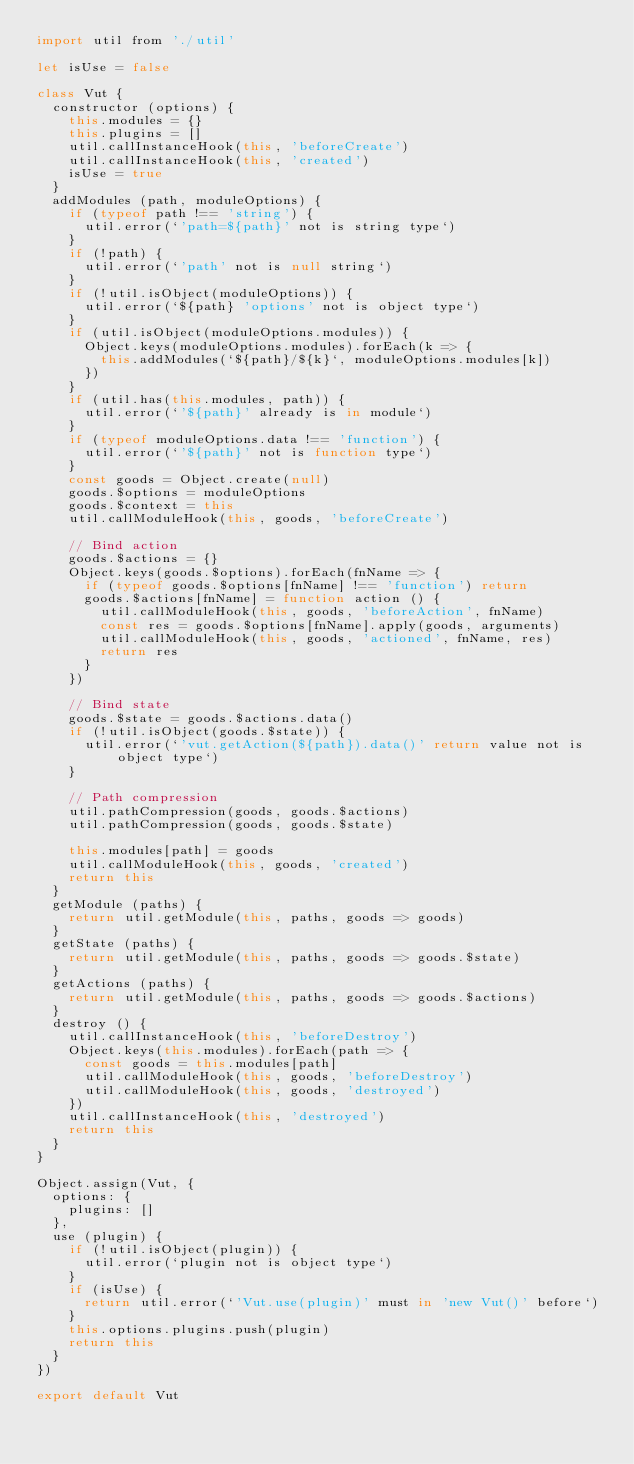<code> <loc_0><loc_0><loc_500><loc_500><_JavaScript_>import util from './util'

let isUse = false

class Vut {
  constructor (options) {
    this.modules = {}
    this.plugins = []
    util.callInstanceHook(this, 'beforeCreate')
    util.callInstanceHook(this, 'created')
    isUse = true
  }
  addModules (path, moduleOptions) {
    if (typeof path !== 'string') {
      util.error(`'path=${path}' not is string type`)
    }
    if (!path) {
      util.error(`'path' not is null string`)
    }
    if (!util.isObject(moduleOptions)) {
      util.error(`${path} 'options' not is object type`)
    }
    if (util.isObject(moduleOptions.modules)) {
      Object.keys(moduleOptions.modules).forEach(k => {
        this.addModules(`${path}/${k}`, moduleOptions.modules[k])
      })
    }
    if (util.has(this.modules, path)) {
      util.error(`'${path}' already is in module`)
    }
    if (typeof moduleOptions.data !== 'function') {
      util.error(`'${path}' not is function type`)
    }
    const goods = Object.create(null)
    goods.$options = moduleOptions
    goods.$context = this
    util.callModuleHook(this, goods, 'beforeCreate')

    // Bind action
    goods.$actions = {}
    Object.keys(goods.$options).forEach(fnName => {
      if (typeof goods.$options[fnName] !== 'function') return
      goods.$actions[fnName] = function action () {
        util.callModuleHook(this, goods, 'beforeAction', fnName)
        const res = goods.$options[fnName].apply(goods, arguments)
        util.callModuleHook(this, goods, 'actioned', fnName, res)
        return res
      }
    })

    // Bind state
    goods.$state = goods.$actions.data()
    if (!util.isObject(goods.$state)) {
      util.error(`'vut.getAction(${path}).data()' return value not is object type`)
    }

    // Path compression
    util.pathCompression(goods, goods.$actions)
    util.pathCompression(goods, goods.$state)

    this.modules[path] = goods
    util.callModuleHook(this, goods, 'created')
    return this
  }
  getModule (paths) {
    return util.getModule(this, paths, goods => goods)
  }
  getState (paths) {
    return util.getModule(this, paths, goods => goods.$state)
  }
  getActions (paths) {
    return util.getModule(this, paths, goods => goods.$actions)
  }
  destroy () {
    util.callInstanceHook(this, 'beforeDestroy')
    Object.keys(this.modules).forEach(path => {
      const goods = this.modules[path]
      util.callModuleHook(this, goods, 'beforeDestroy')
      util.callModuleHook(this, goods, 'destroyed')
    })
    util.callInstanceHook(this, 'destroyed')
    return this
  }
}

Object.assign(Vut, {
  options: {
    plugins: []
  },
  use (plugin) {
    if (!util.isObject(plugin)) {
      util.error(`plugin not is object type`)
    }
    if (isUse) {
      return util.error(`'Vut.use(plugin)' must in 'new Vut()' before`)
    }
    this.options.plugins.push(plugin)
    return this
  }
})

export default Vut
</code> 